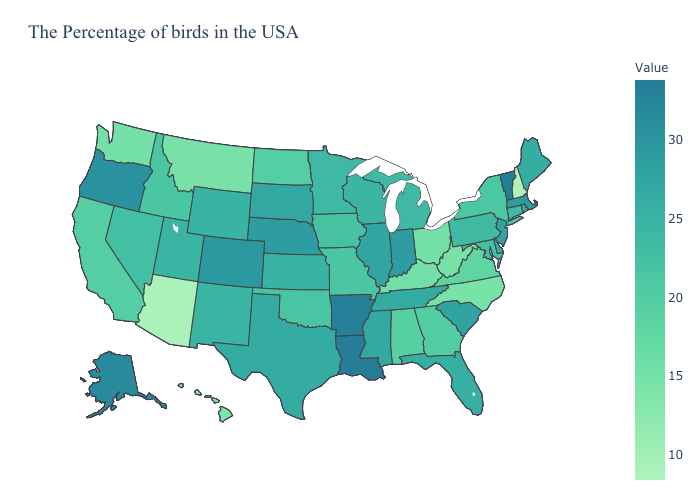Which states have the highest value in the USA?
Concise answer only. Louisiana. Among the states that border Minnesota , which have the highest value?
Concise answer only. South Dakota. Among the states that border Nevada , does Oregon have the lowest value?
Write a very short answer. No. Does North Carolina have the lowest value in the South?
Answer briefly. Yes. Which states have the lowest value in the MidWest?
Keep it brief. Ohio. Among the states that border Kansas , which have the lowest value?
Keep it brief. Missouri. Which states have the highest value in the USA?
Quick response, please. Louisiana. Among the states that border Iowa , which have the lowest value?
Short answer required. Missouri. Which states have the highest value in the USA?
Short answer required. Louisiana. Which states have the lowest value in the USA?
Quick response, please. New Hampshire. 